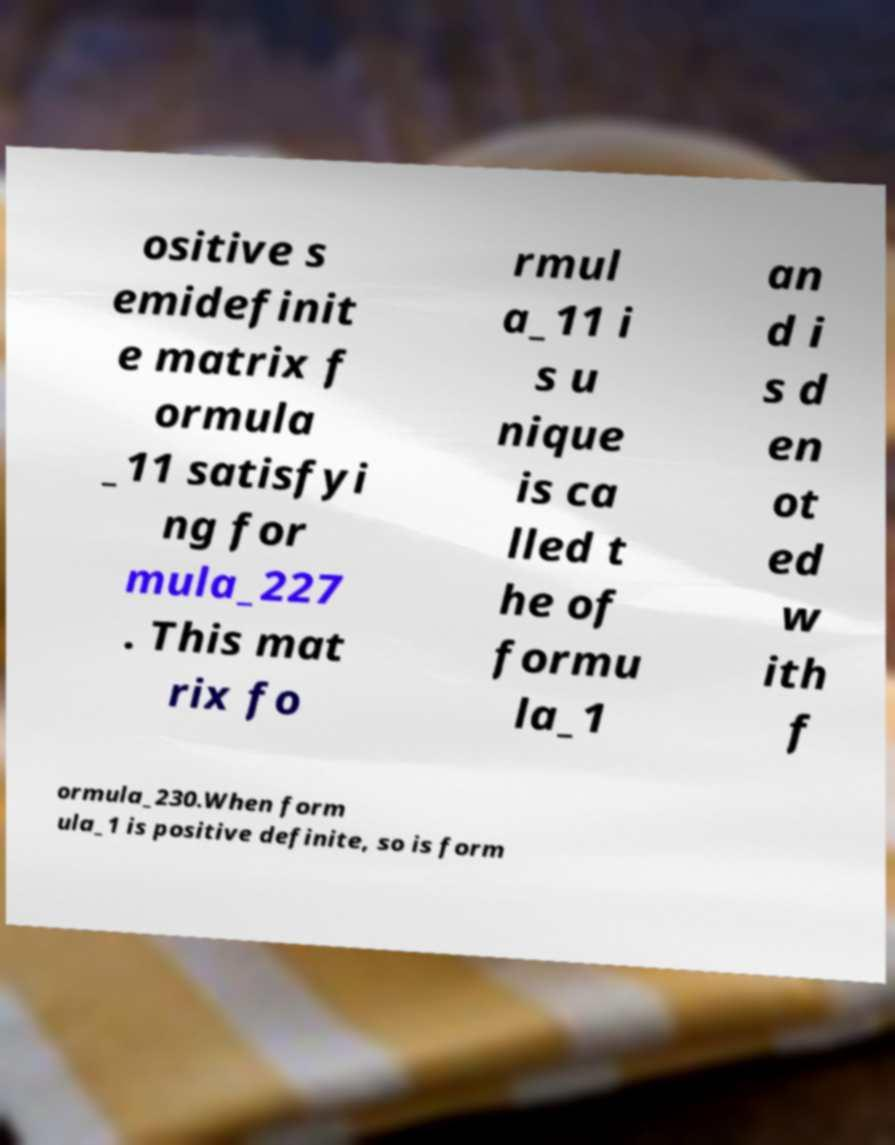Can you read and provide the text displayed in the image?This photo seems to have some interesting text. Can you extract and type it out for me? ositive s emidefinit e matrix f ormula _11 satisfyi ng for mula_227 . This mat rix fo rmul a_11 i s u nique is ca lled t he of formu la_1 an d i s d en ot ed w ith f ormula_230.When form ula_1 is positive definite, so is form 